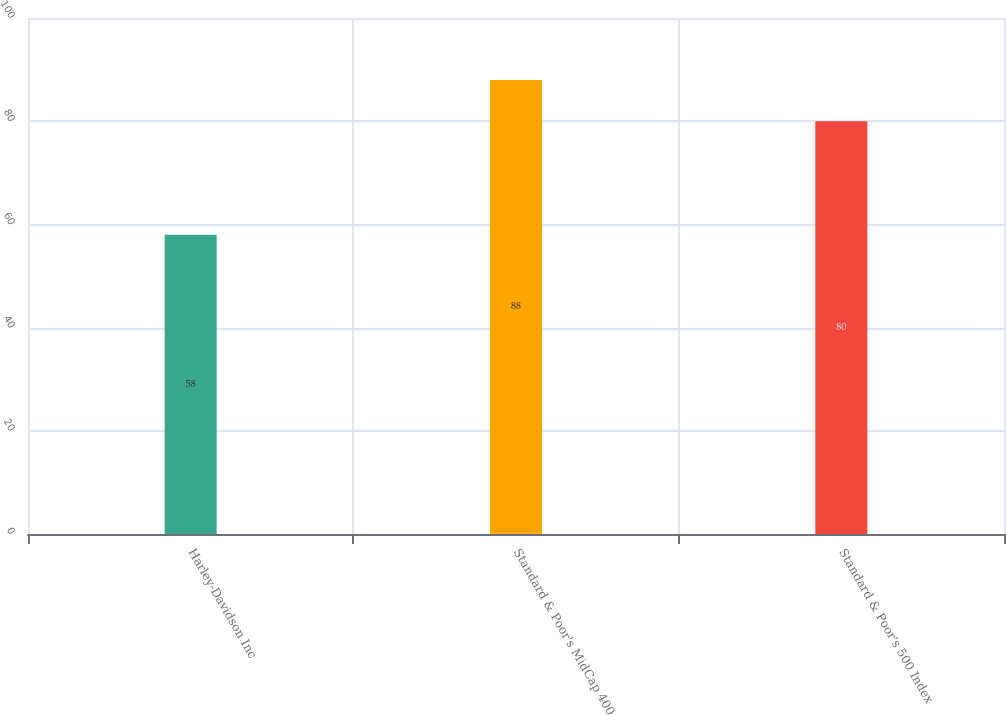Convert chart. <chart><loc_0><loc_0><loc_500><loc_500><bar_chart><fcel>Harley-Davidson Inc<fcel>Standard & Poor's MidCap 400<fcel>Standard & Poor's 500 Index<nl><fcel>58<fcel>88<fcel>80<nl></chart> 